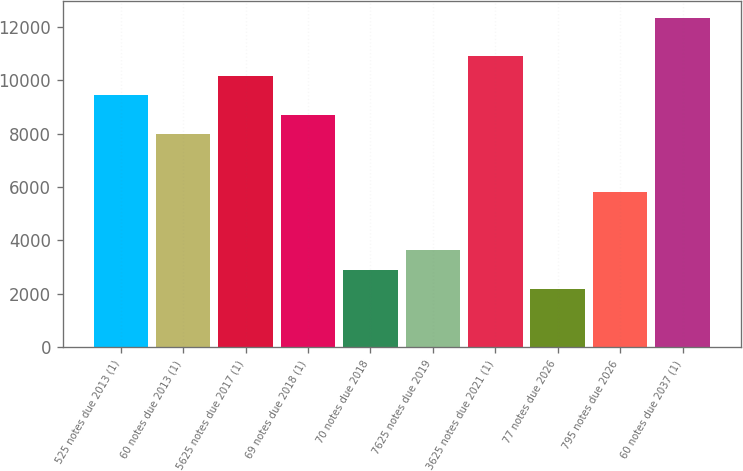Convert chart. <chart><loc_0><loc_0><loc_500><loc_500><bar_chart><fcel>525 notes due 2013 (1)<fcel>60 notes due 2013 (1)<fcel>5625 notes due 2017 (1)<fcel>69 notes due 2018 (1)<fcel>70 notes due 2018<fcel>7625 notes due 2019<fcel>3625 notes due 2021 (1)<fcel>77 notes due 2026<fcel>795 notes due 2026<fcel>60 notes due 2037 (1)<nl><fcel>9440.3<fcel>7988.1<fcel>10166.4<fcel>8714.2<fcel>2905.4<fcel>3631.5<fcel>10892.5<fcel>2179.3<fcel>5809.8<fcel>12344.7<nl></chart> 